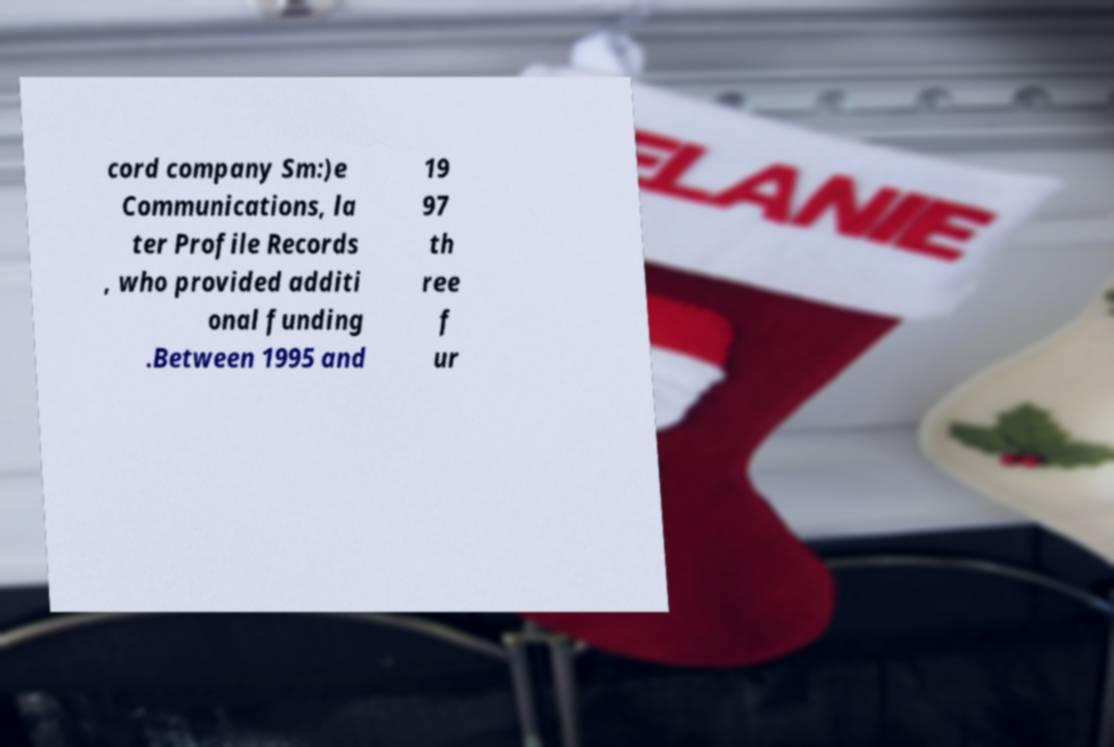Please read and relay the text visible in this image. What does it say? cord company Sm:)e Communications, la ter Profile Records , who provided additi onal funding .Between 1995 and 19 97 th ree f ur 